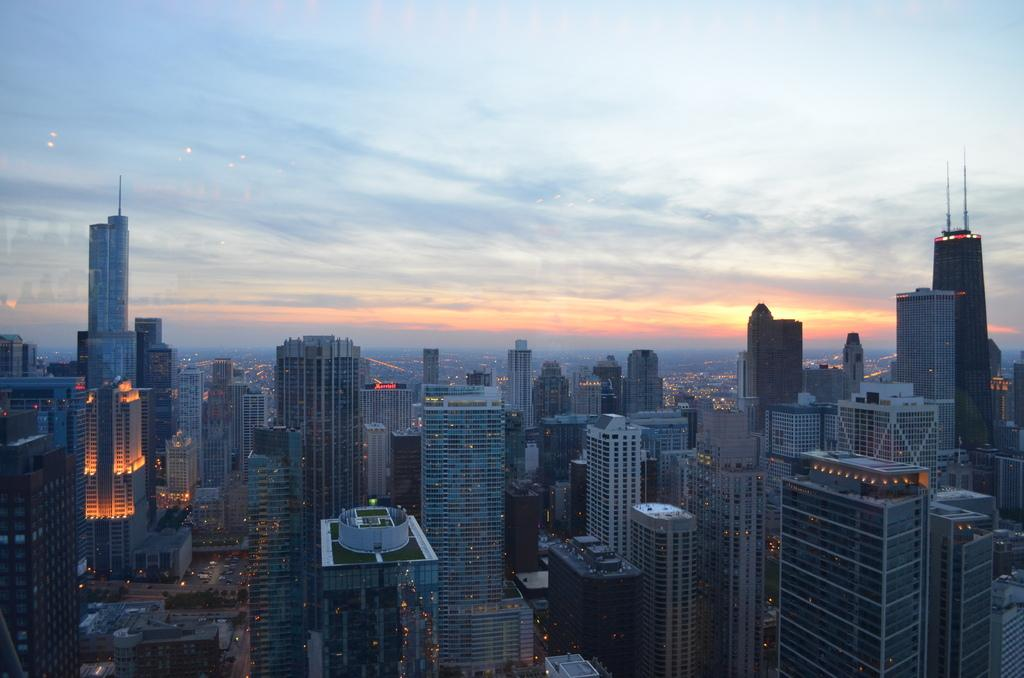What type of structures can be seen in the image? There are buildings in the image. Are there any other elements visible in the image besides the buildings? Yes, there are lights in the image. Where are the buildings and lights located in the image? The buildings and lights are at the bottom side of the image. What can be seen at the top side of the image? The sky is visible at the top side of the image. How many kittens are wearing collars in the image? There are no kittens or collars present in the image. What type of record can be seen playing in the background of the image? There is no record playing in the background of the image; it only features buildings, lights, and the sky. 